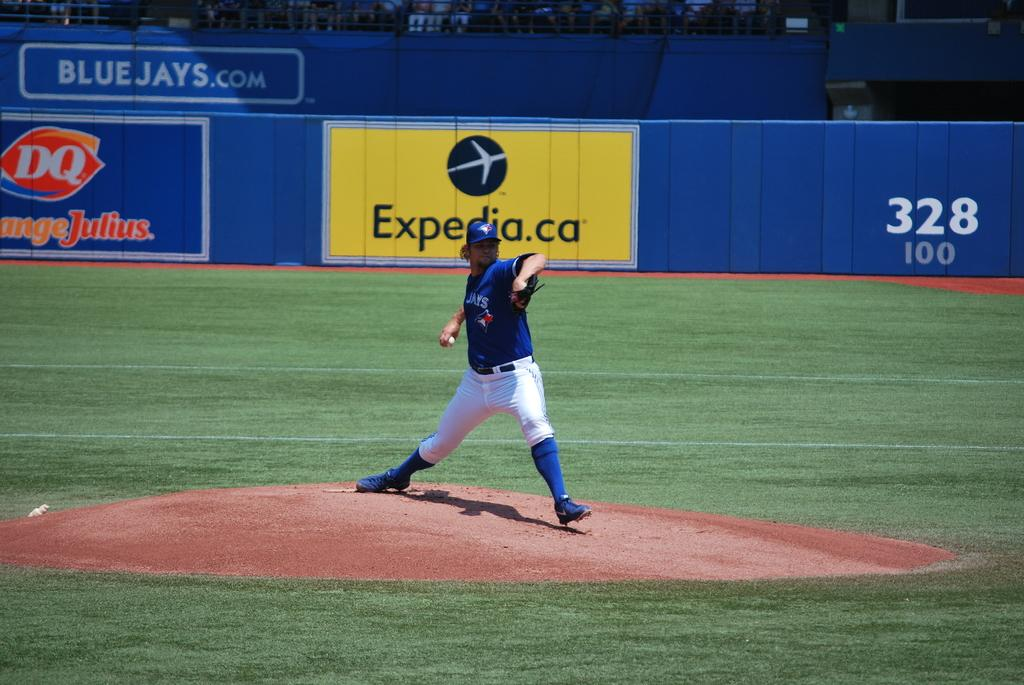<image>
Create a compact narrative representing the image presented. A Blue Jay's player is pitching the ball on a baseball field. 